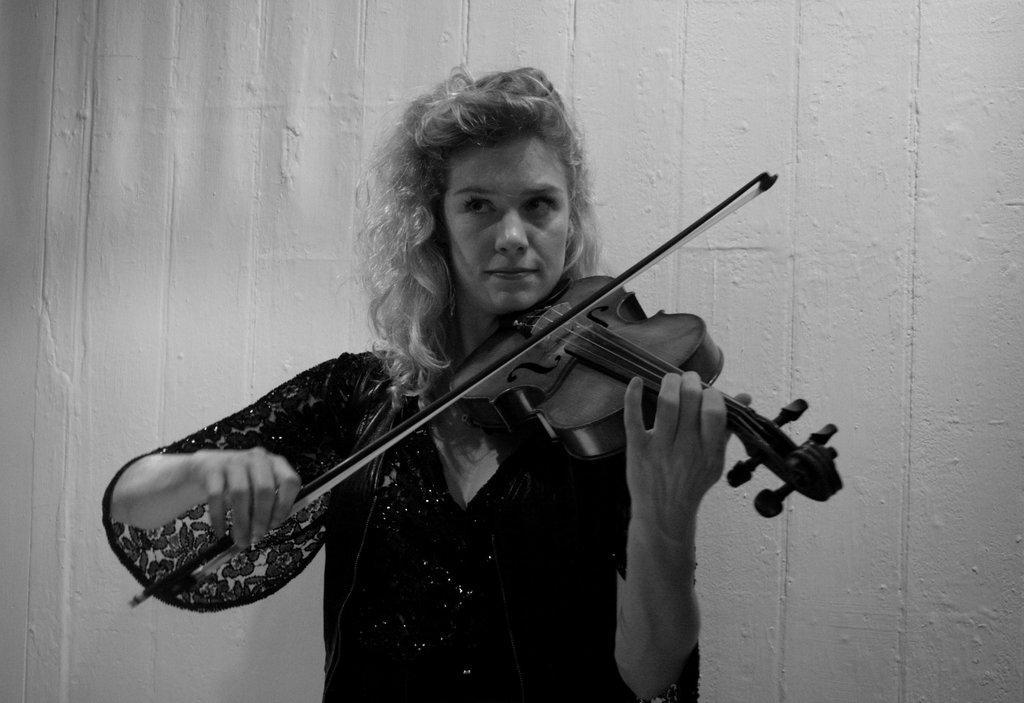How would you summarize this image in a sentence or two? In this image i can see a woman wearing a black dress and holding a musical instrument in her hand. 